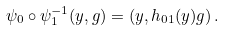<formula> <loc_0><loc_0><loc_500><loc_500>\psi _ { 0 } \circ \psi _ { 1 } ^ { - 1 } ( y , g ) = \left ( y , h _ { 0 1 } ( y ) g \right ) .</formula> 